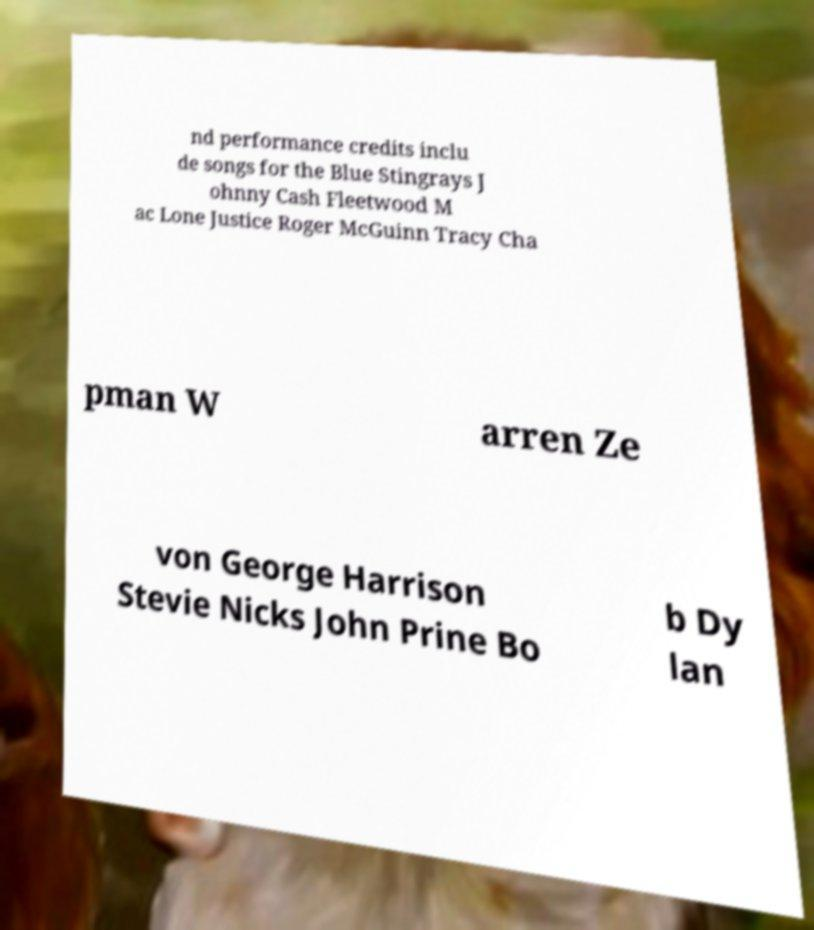Could you assist in decoding the text presented in this image and type it out clearly? nd performance credits inclu de songs for the Blue Stingrays J ohnny Cash Fleetwood M ac Lone Justice Roger McGuinn Tracy Cha pman W arren Ze von George Harrison Stevie Nicks John Prine Bo b Dy lan 